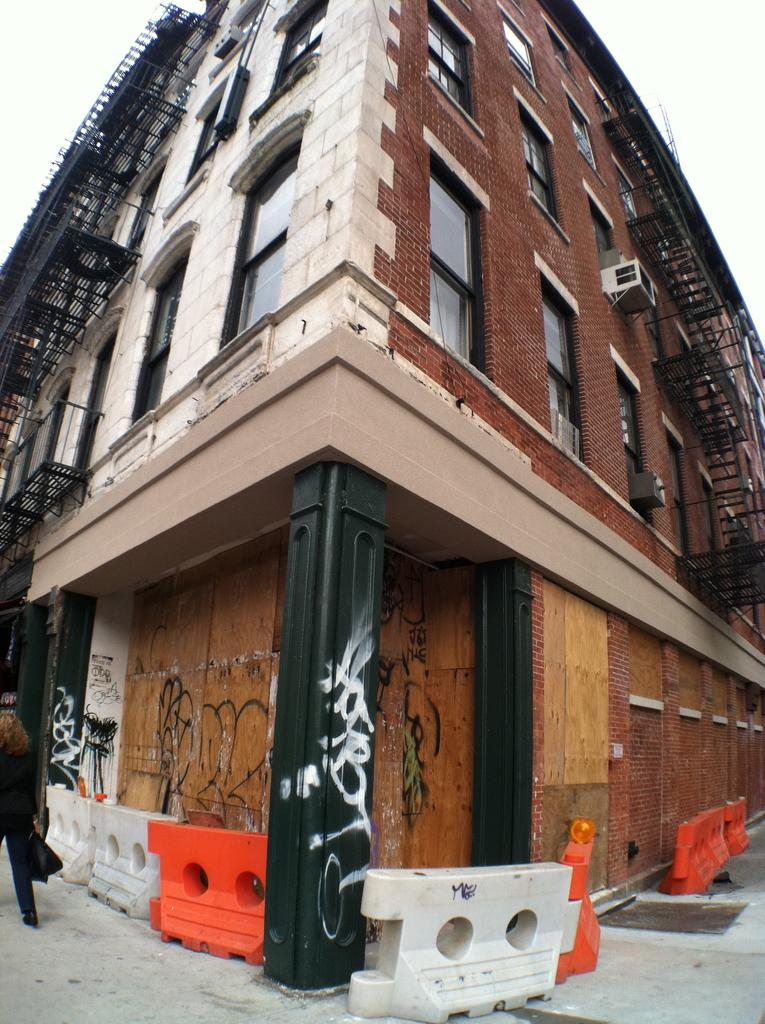What type of path is visible in the image? There is a footpath in the image. What is the woman in the image doing? A woman is walking on the footpath. Can you describe any objects present in the image? There are objects in the image, but their specific nature is not mentioned in the facts. What can be seen in the background of the image? There is a building in the background of the image. What type of ear is visible on the woman's shoe in the image? There is no mention of a shoe or an ear in the image, so this question cannot be answered. 